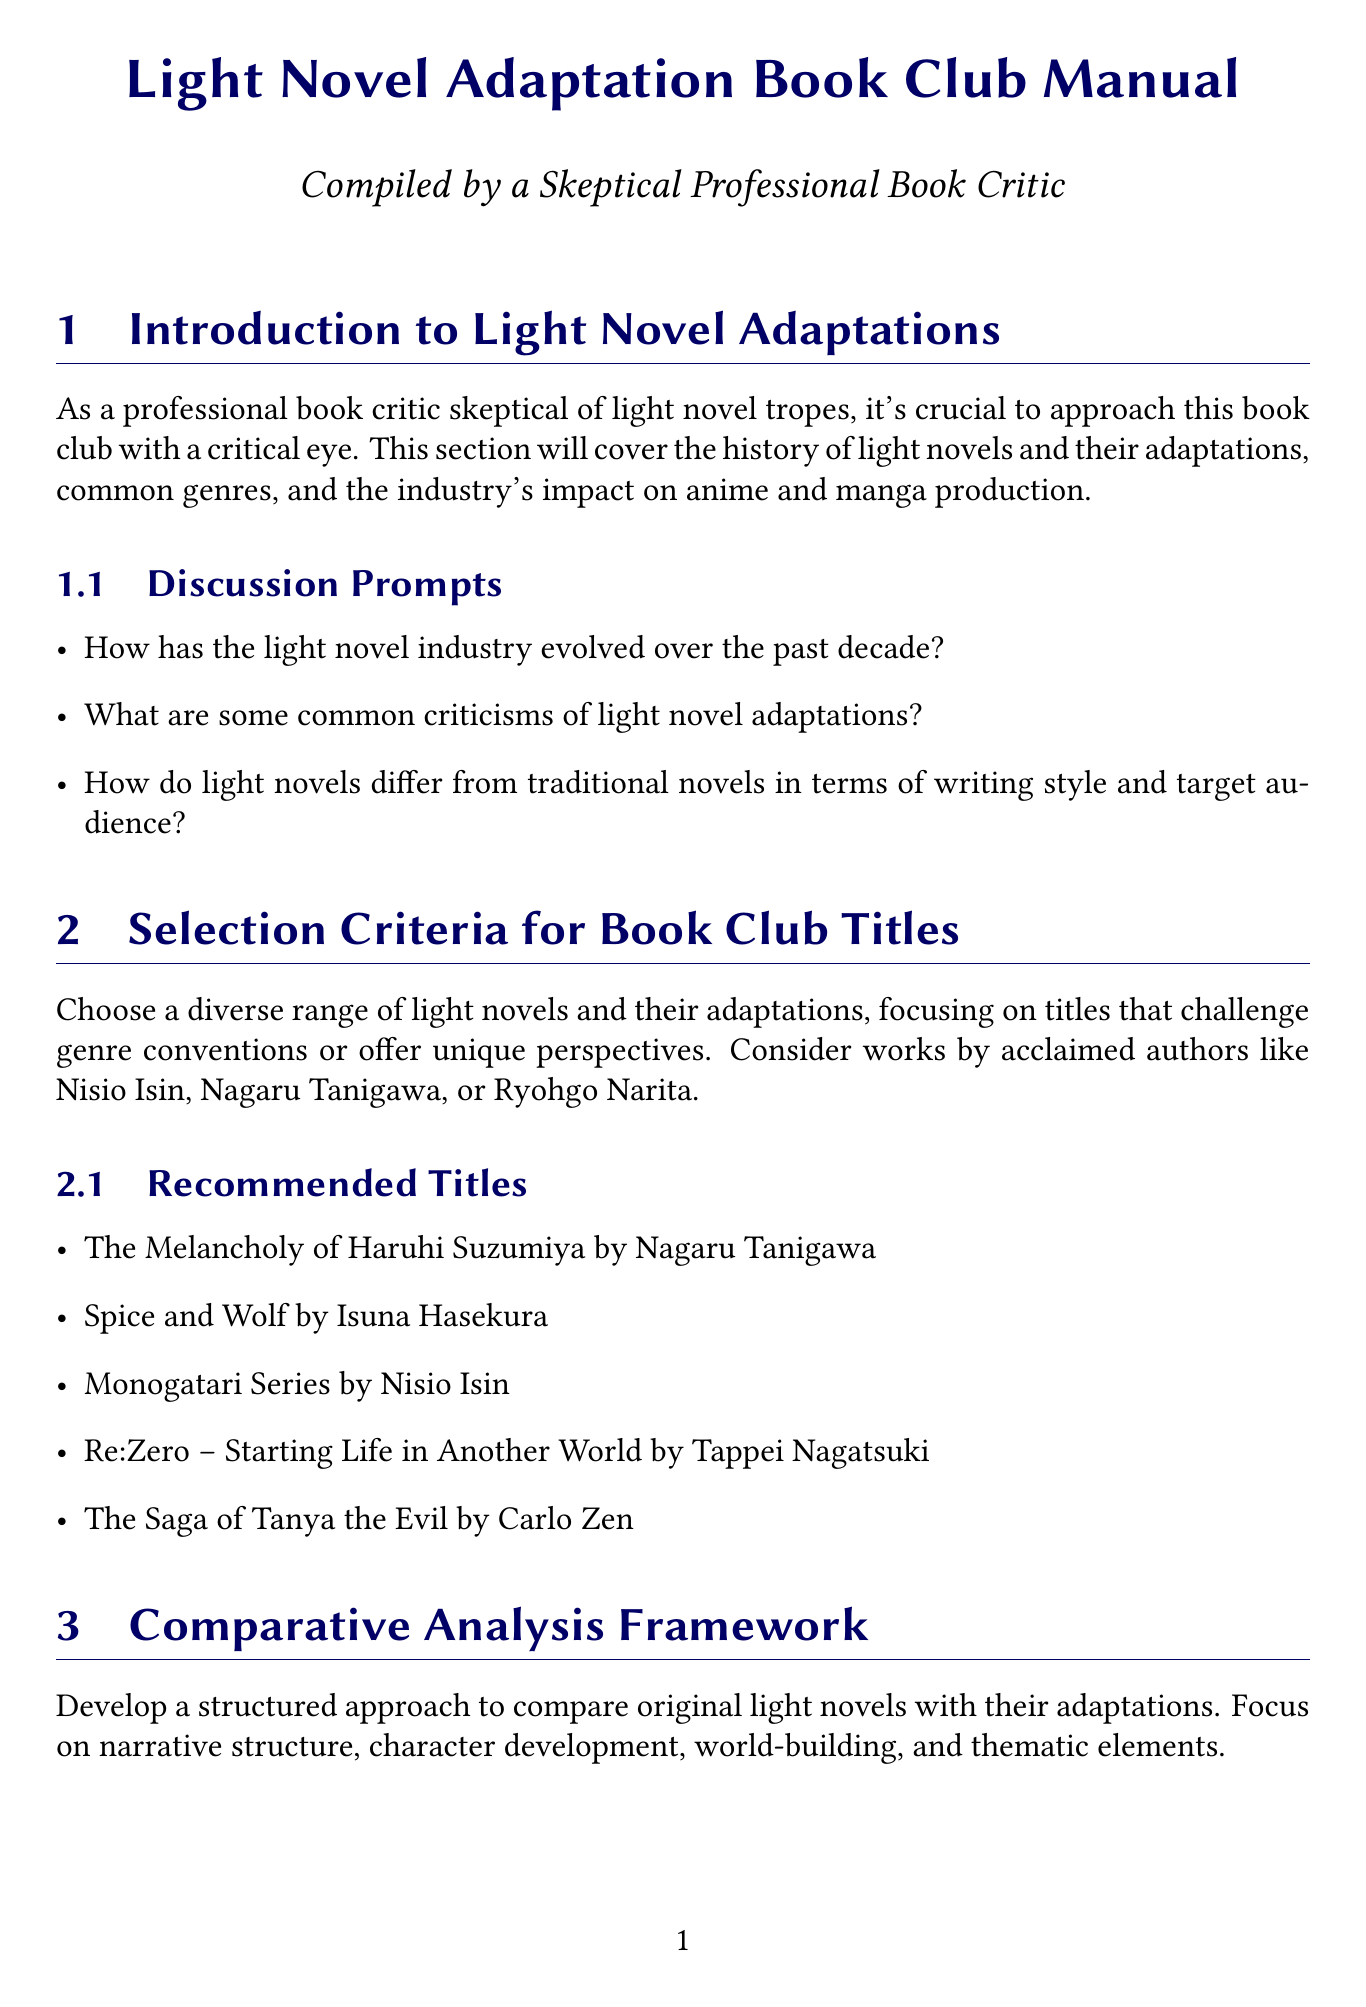What is the recommended group size for the book club? The recommended group size is mentioned in the document under book club logistics.
Answer: 8-12 members How frequently should the book club meet? The document specifies the meeting frequency in the logistics section.
Answer: Monthly Who is an acclaimed author suggested for book selection? The document lists several authors in the selection criteria section.
Answer: Nisio Isin What is one of the common light novel tropes discussed? Common tropes are listed in the section on trope analysis and subversion.
Answer: Isekai What should members prepare before each meeting? The preparation requirements are outlined in the book club logistics.
Answer: Read the selected light novel and watch/read its adaptation Which evaluation criterion focuses on character portrayal? The evaluation criteria section outlines different criteria used for analysis.
Answer: Character portrayal and development What is the session duration for the book club? The session duration is specified in the book club logistics section.
Answer: 2 hours What type of discussion format is recommended? The recommended discussion format is mentioned in book club logistics.
Answer: Moderated group discussion with prepared talking points and open Q&A How does the document suggest analyzing visual storytelling? The analysis points section discusses specific aspects to focus on.
Answer: Use of internal monologue and narration 